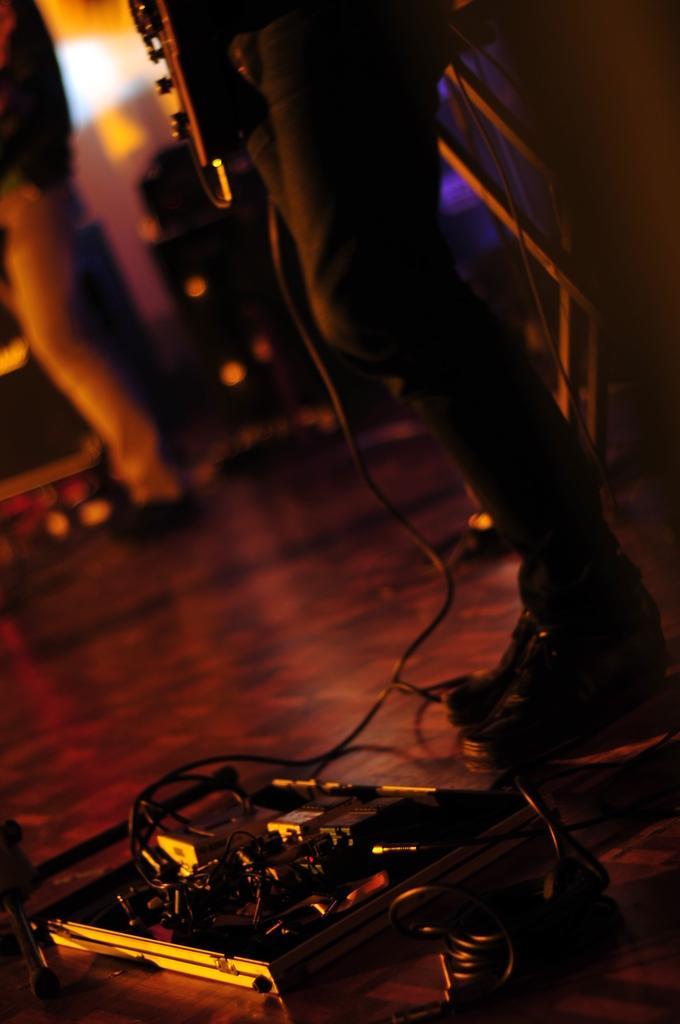Can you describe this image briefly? In this picture I can see two persons standing, it looks like a music system, there are cables on the floor, and there is blur background. 